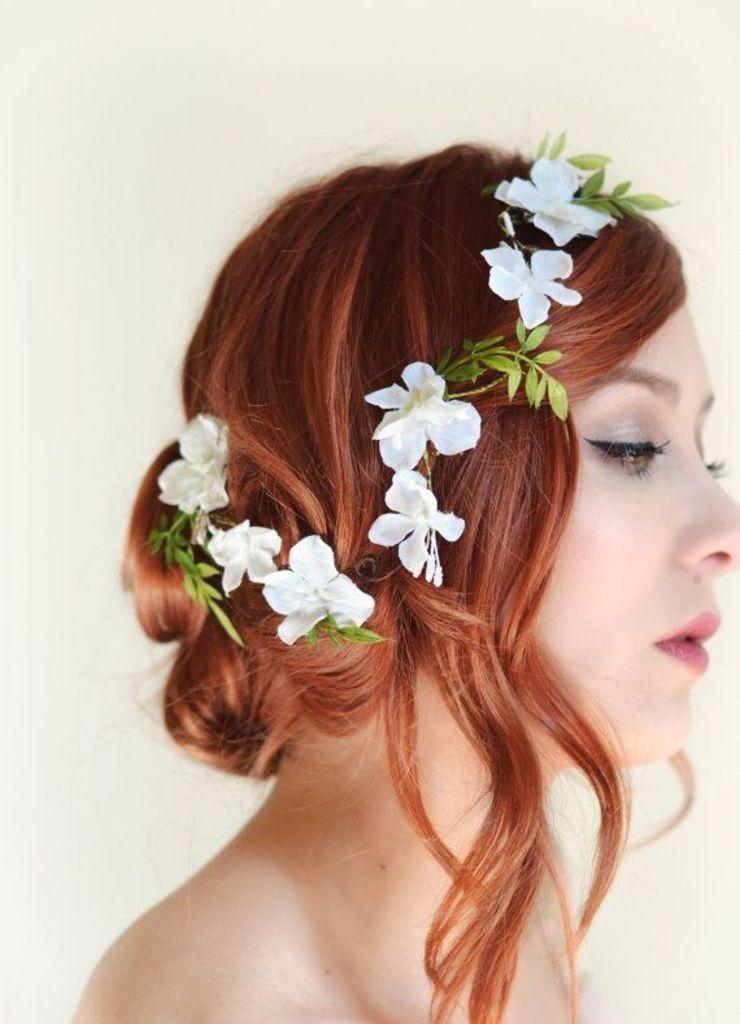Who is the main subject in the image? There is a woman in the image. What is the woman wearing on her head? The woman is wearing a flower crown. What color is the background of the image? The background of the image is cream-colored. How many steps does the woman take in the image? There is no indication of the woman taking any steps in the image, as it appears to be a still photograph. 